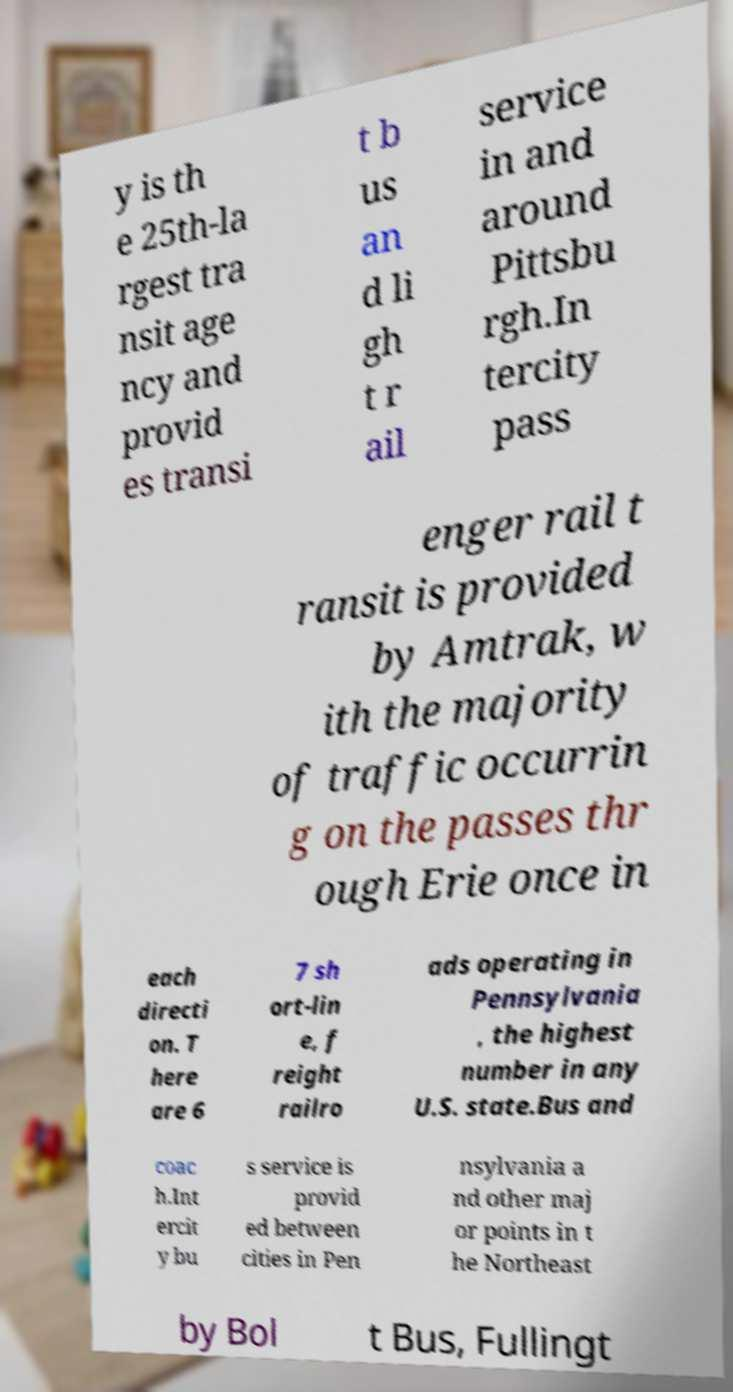Please identify and transcribe the text found in this image. y is th e 25th-la rgest tra nsit age ncy and provid es transi t b us an d li gh t r ail service in and around Pittsbu rgh.In tercity pass enger rail t ransit is provided by Amtrak, w ith the majority of traffic occurrin g on the passes thr ough Erie once in each directi on. T here are 6 7 sh ort-lin e, f reight railro ads operating in Pennsylvania , the highest number in any U.S. state.Bus and coac h.Int ercit y bu s service is provid ed between cities in Pen nsylvania a nd other maj or points in t he Northeast by Bol t Bus, Fullingt 